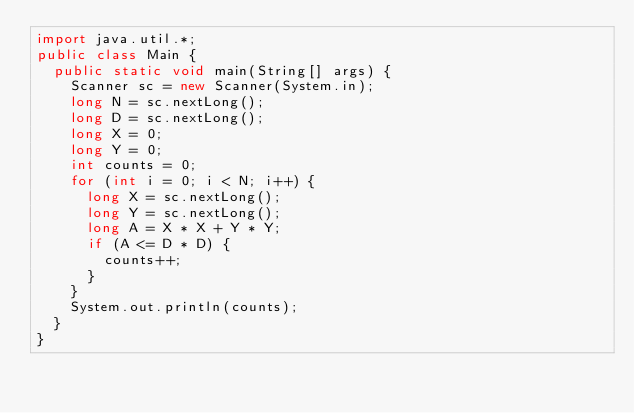Convert code to text. <code><loc_0><loc_0><loc_500><loc_500><_Java_>import java.util.*;
public class Main {
  public static void main(String[] args) {
    Scanner sc = new Scanner(System.in);
    long N = sc.nextLong();
    long D = sc.nextLong();
    long X = 0;
    long Y = 0;
    int counts = 0;
    for (int i = 0; i < N; i++) {
      long X = sc.nextLong();
      long Y = sc.nextLong();
      long A = X * X + Y * Y;
      if (A <= D * D) {
        counts++;
      }
    }
    System.out.println(counts);
  }
}
</code> 